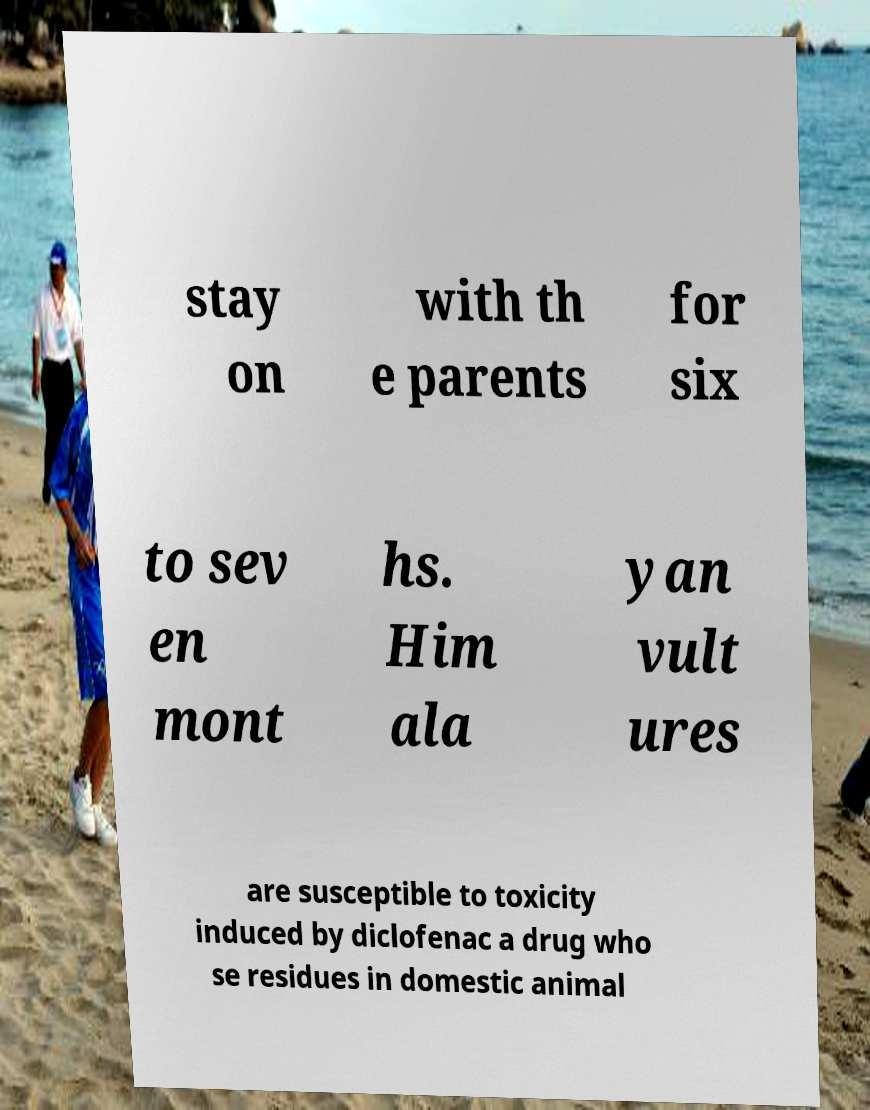I need the written content from this picture converted into text. Can you do that? stay on with th e parents for six to sev en mont hs. Him ala yan vult ures are susceptible to toxicity induced by diclofenac a drug who se residues in domestic animal 